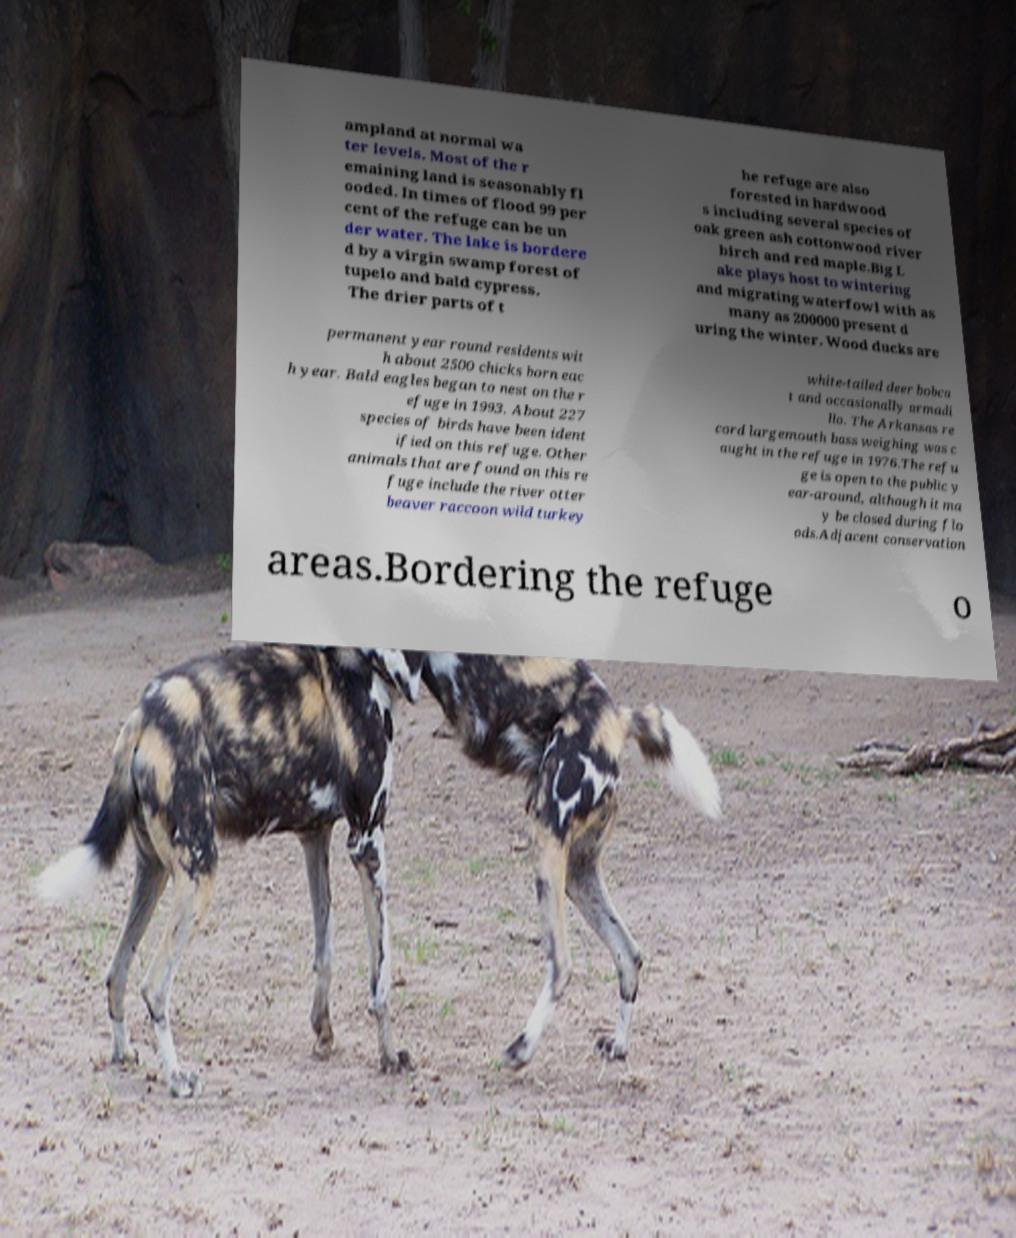Please identify and transcribe the text found in this image. ampland at normal wa ter levels. Most of the r emaining land is seasonably fl ooded. In times of flood 99 per cent of the refuge can be un der water. The lake is bordere d by a virgin swamp forest of tupelo and bald cypress. The drier parts of t he refuge are also forested in hardwood s including several species of oak green ash cottonwood river birch and red maple.Big L ake plays host to wintering and migrating waterfowl with as many as 200000 present d uring the winter. Wood ducks are permanent year round residents wit h about 2500 chicks born eac h year. Bald eagles began to nest on the r efuge in 1993. About 227 species of birds have been ident ified on this refuge. Other animals that are found on this re fuge include the river otter beaver raccoon wild turkey white-tailed deer bobca t and occasionally armadi llo. The Arkansas re cord largemouth bass weighing was c aught in the refuge in 1976.The refu ge is open to the public y ear-around, although it ma y be closed during flo ods.Adjacent conservation areas.Bordering the refuge o 